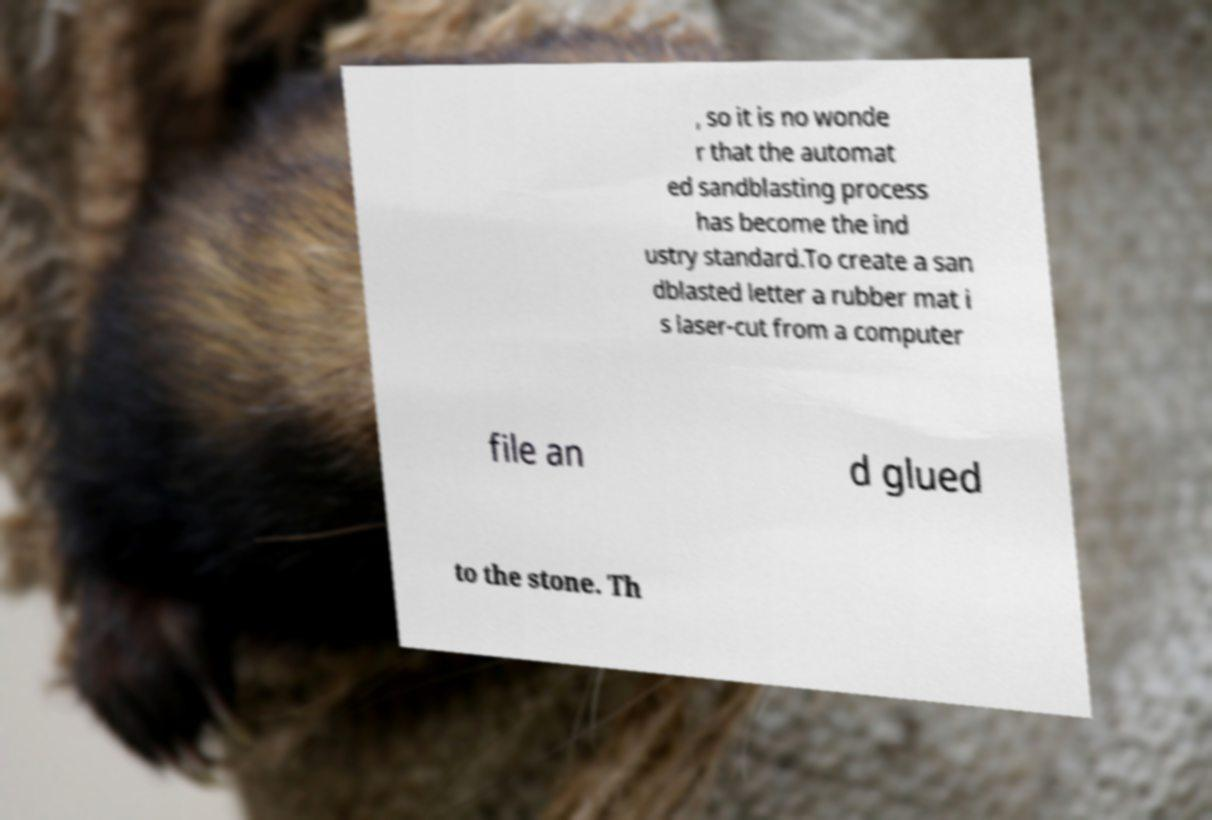Could you assist in decoding the text presented in this image and type it out clearly? , so it is no wonde r that the automat ed sandblasting process has become the ind ustry standard.To create a san dblasted letter a rubber mat i s laser-cut from a computer file an d glued to the stone. Th 